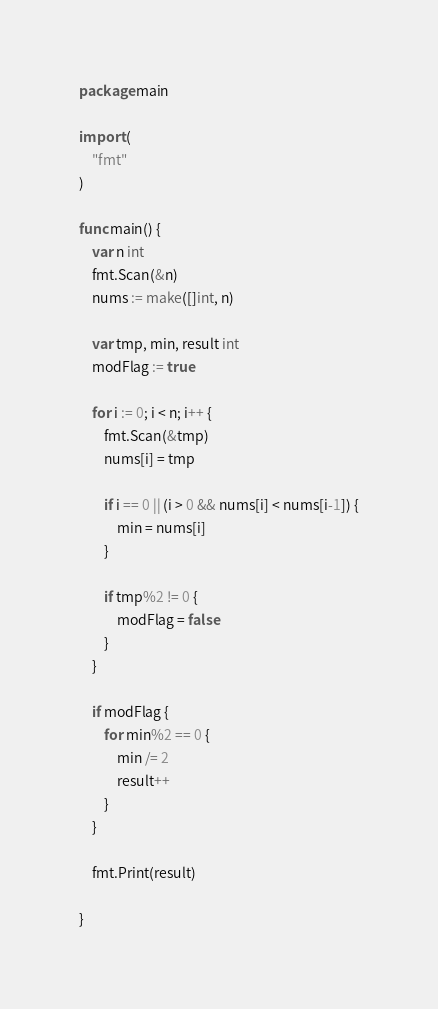Convert code to text. <code><loc_0><loc_0><loc_500><loc_500><_Go_>package main

import (
	"fmt"
)

func main() {
	var n int
	fmt.Scan(&n)
	nums := make([]int, n)

	var tmp, min, result int
	modFlag := true

	for i := 0; i < n; i++ {
		fmt.Scan(&tmp)
		nums[i] = tmp

		if i == 0 || (i > 0 && nums[i] < nums[i-1]) {
			min = nums[i]
		}

		if tmp%2 != 0 {
			modFlag = false
		}
	}

	if modFlag {
		for min%2 == 0 {
			min /= 2
			result++
		}
	}

	fmt.Print(result)

}
</code> 